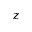Convert formula to latex. <formula><loc_0><loc_0><loc_500><loc_500>z</formula> 